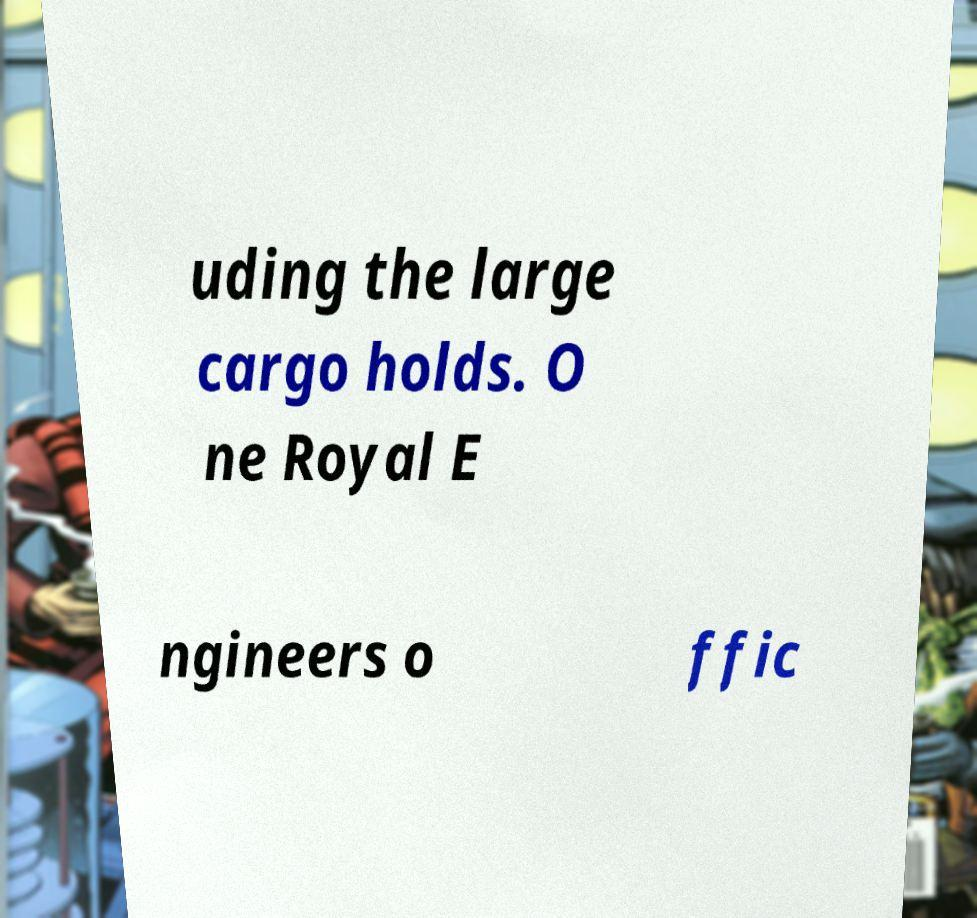Could you assist in decoding the text presented in this image and type it out clearly? uding the large cargo holds. O ne Royal E ngineers o ffic 